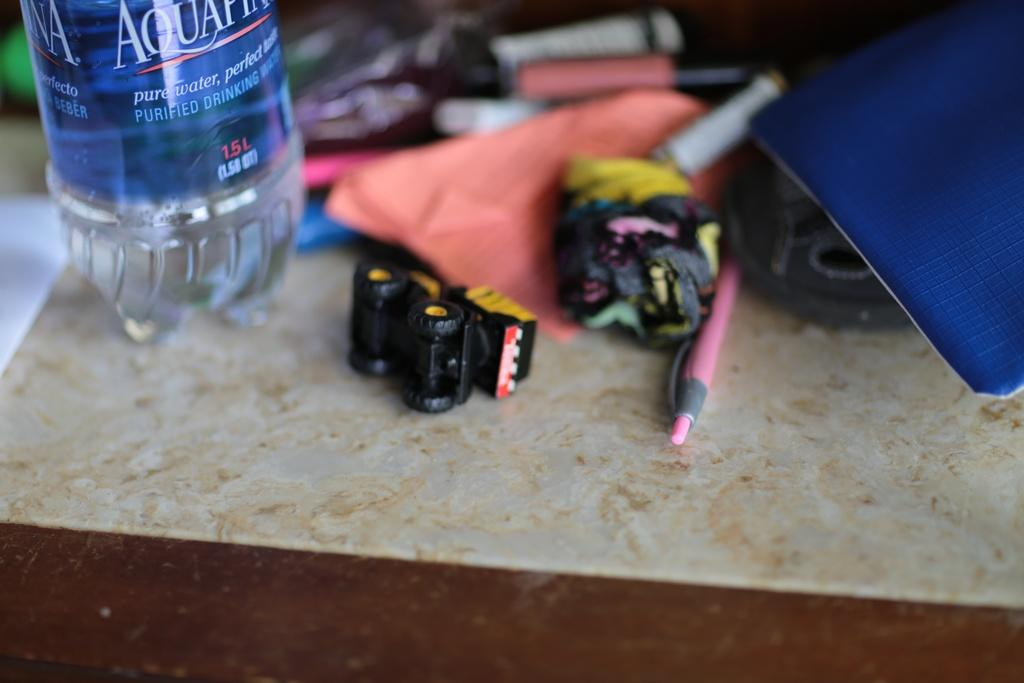What is one of the objects placed on the table in the image? There is a bottle in the image. What is another object placed on the table in the image? There is a pen in the image. What is the third object placed on the table in the image? There is paper in the image. What type of items can be seen on the table that are not writing or drinking utensils? There are toys in the image. How does the wind affect the objects on the table in the image? There is no wind present in the image, so it does not affect the objects on the table. What symbol of peace can be seen on the table in the image? There is no specific symbol of peace present in the image. 